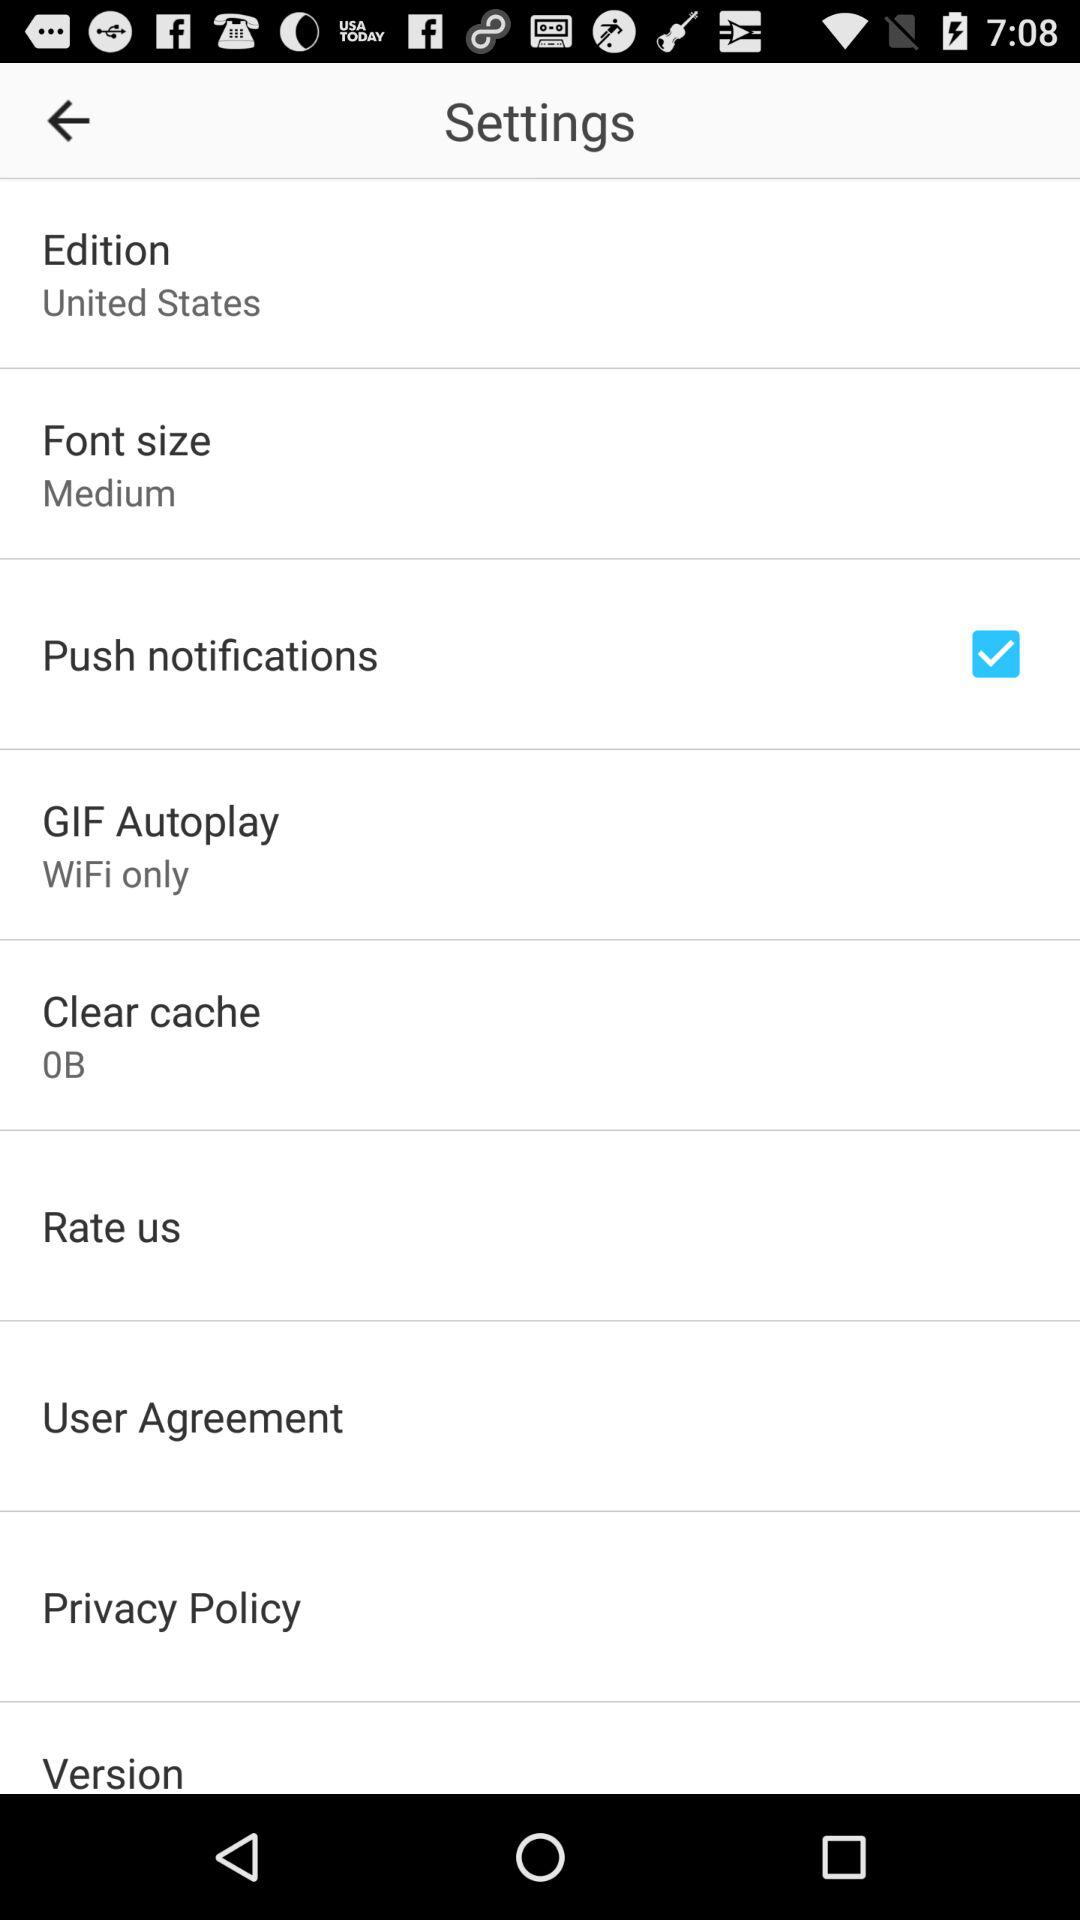How many items in the settings section have a check box?
Answer the question using a single word or phrase. 1 